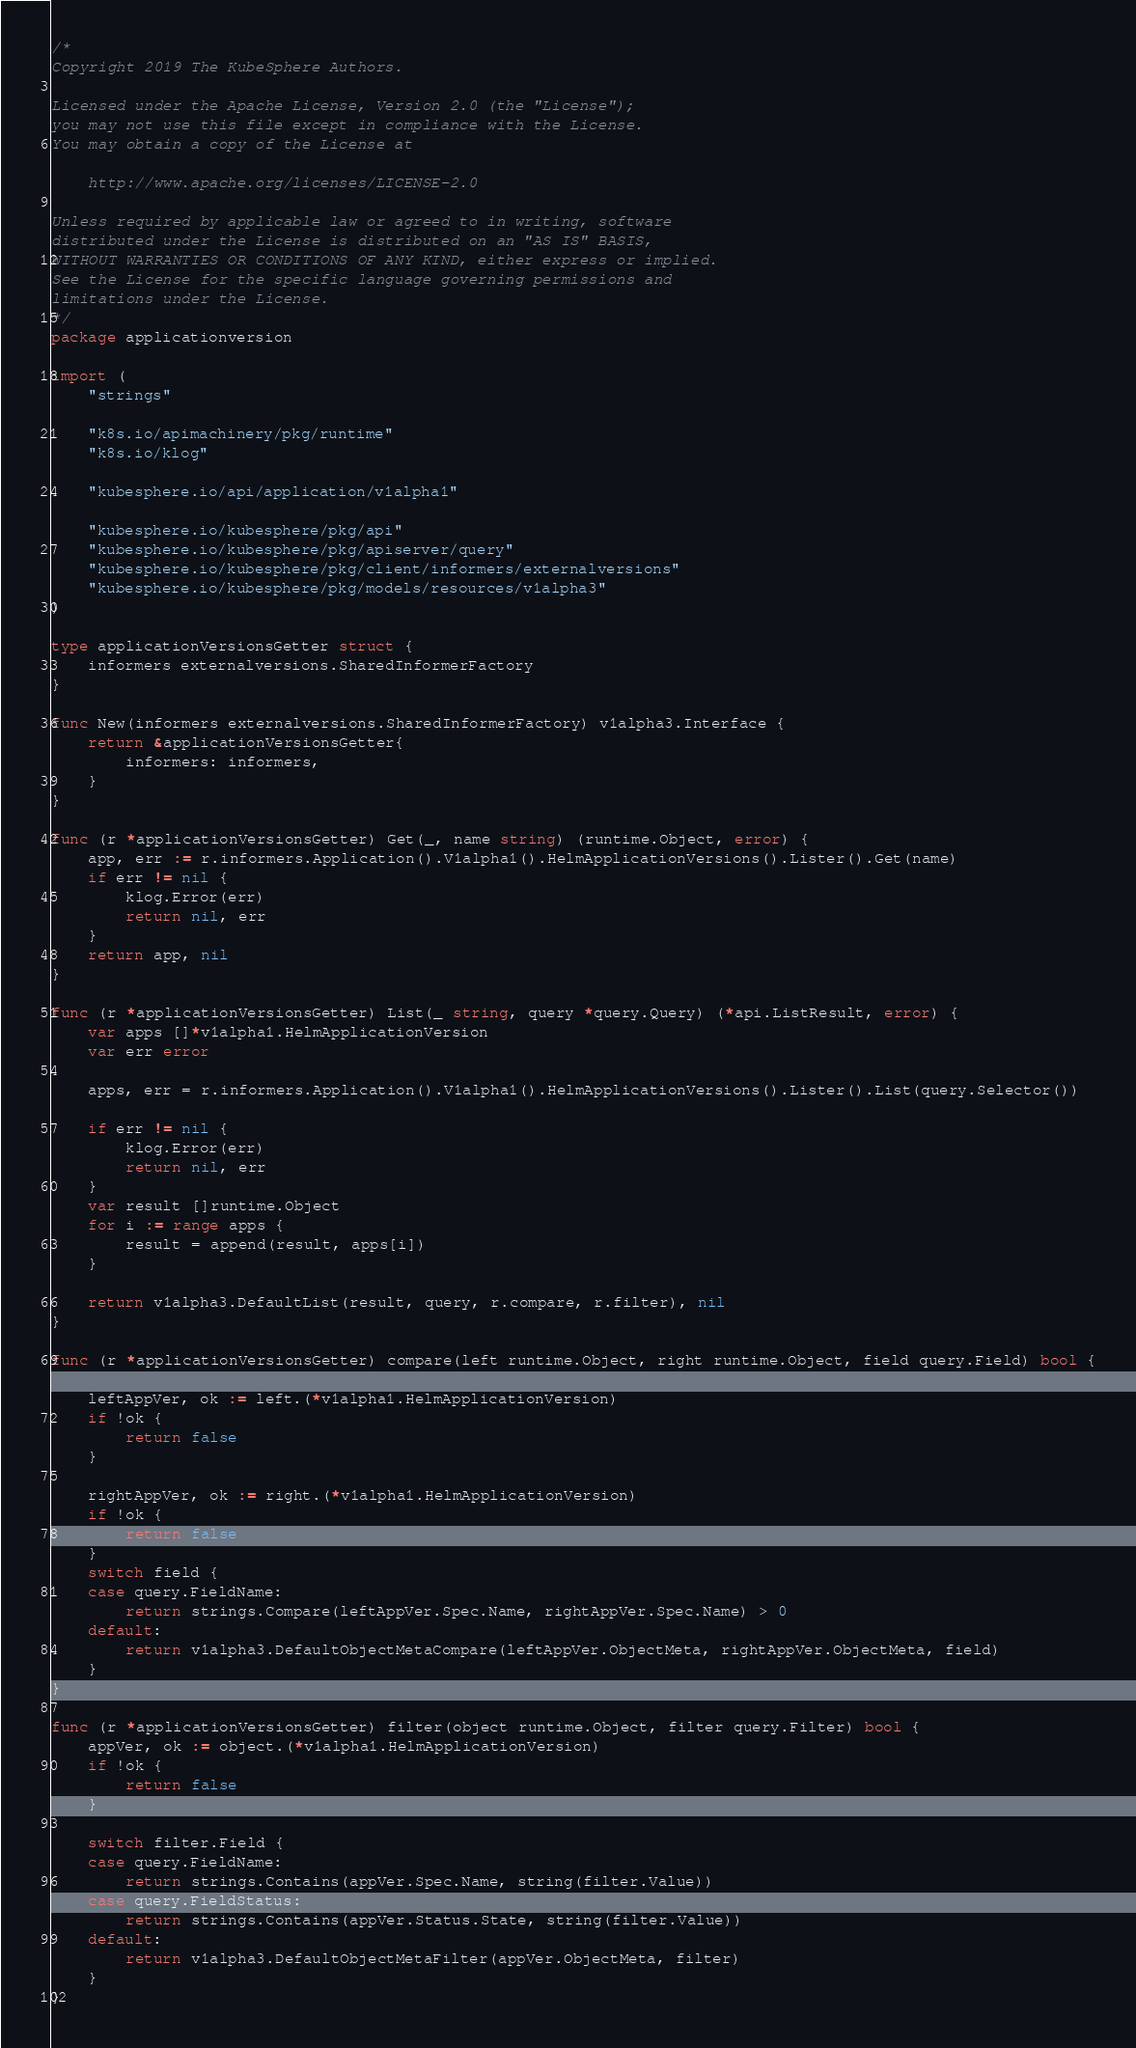<code> <loc_0><loc_0><loc_500><loc_500><_Go_>/*
Copyright 2019 The KubeSphere Authors.

Licensed under the Apache License, Version 2.0 (the "License");
you may not use this file except in compliance with the License.
You may obtain a copy of the License at

    http://www.apache.org/licenses/LICENSE-2.0

Unless required by applicable law or agreed to in writing, software
distributed under the License is distributed on an "AS IS" BASIS,
WITHOUT WARRANTIES OR CONDITIONS OF ANY KIND, either express or implied.
See the License for the specific language governing permissions and
limitations under the License.
*/
package applicationversion

import (
	"strings"

	"k8s.io/apimachinery/pkg/runtime"
	"k8s.io/klog"

	"kubesphere.io/api/application/v1alpha1"

	"kubesphere.io/kubesphere/pkg/api"
	"kubesphere.io/kubesphere/pkg/apiserver/query"
	"kubesphere.io/kubesphere/pkg/client/informers/externalversions"
	"kubesphere.io/kubesphere/pkg/models/resources/v1alpha3"
)

type applicationVersionsGetter struct {
	informers externalversions.SharedInformerFactory
}

func New(informers externalversions.SharedInformerFactory) v1alpha3.Interface {
	return &applicationVersionsGetter{
		informers: informers,
	}
}

func (r *applicationVersionsGetter) Get(_, name string) (runtime.Object, error) {
	app, err := r.informers.Application().V1alpha1().HelmApplicationVersions().Lister().Get(name)
	if err != nil {
		klog.Error(err)
		return nil, err
	}
	return app, nil
}

func (r *applicationVersionsGetter) List(_ string, query *query.Query) (*api.ListResult, error) {
	var apps []*v1alpha1.HelmApplicationVersion
	var err error

	apps, err = r.informers.Application().V1alpha1().HelmApplicationVersions().Lister().List(query.Selector())

	if err != nil {
		klog.Error(err)
		return nil, err
	}
	var result []runtime.Object
	for i := range apps {
		result = append(result, apps[i])
	}

	return v1alpha3.DefaultList(result, query, r.compare, r.filter), nil
}

func (r *applicationVersionsGetter) compare(left runtime.Object, right runtime.Object, field query.Field) bool {

	leftAppVer, ok := left.(*v1alpha1.HelmApplicationVersion)
	if !ok {
		return false
	}

	rightAppVer, ok := right.(*v1alpha1.HelmApplicationVersion)
	if !ok {
		return false
	}
	switch field {
	case query.FieldName:
		return strings.Compare(leftAppVer.Spec.Name, rightAppVer.Spec.Name) > 0
	default:
		return v1alpha3.DefaultObjectMetaCompare(leftAppVer.ObjectMeta, rightAppVer.ObjectMeta, field)
	}
}

func (r *applicationVersionsGetter) filter(object runtime.Object, filter query.Filter) bool {
	appVer, ok := object.(*v1alpha1.HelmApplicationVersion)
	if !ok {
		return false
	}

	switch filter.Field {
	case query.FieldName:
		return strings.Contains(appVer.Spec.Name, string(filter.Value))
	case query.FieldStatus:
		return strings.Contains(appVer.Status.State, string(filter.Value))
	default:
		return v1alpha3.DefaultObjectMetaFilter(appVer.ObjectMeta, filter)
	}
}
</code> 